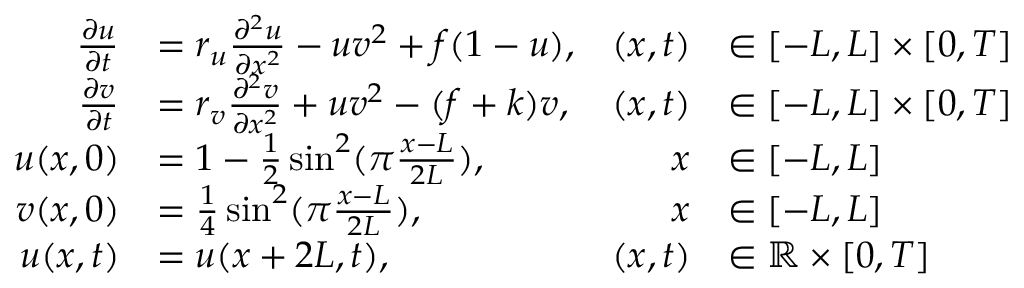<formula> <loc_0><loc_0><loc_500><loc_500>\begin{array} { r l r l } { \frac { \partial u } { \partial t } } & { = r _ { u } \frac { \partial ^ { 2 } u } { \partial x ^ { 2 } } - u v ^ { 2 } + f ( 1 - u ) , } & { ( x , t ) } & { \in [ - L , L ] \times [ 0 , T ] } \\ { \frac { \partial v } { \partial t } } & { = r _ { v } \frac { \partial ^ { 2 } v } { \partial x ^ { 2 } } + u v ^ { 2 } - ( f + k ) v , } & { ( x , t ) } & { \in [ - L , L ] \times [ 0 , T ] } \\ { u ( x , 0 ) } & { = 1 - \frac { 1 } { 2 } \sin ^ { 2 } ( \pi \frac { x - L } { 2 L } ) , } & { x } & { \in [ - L , L ] } \\ { v ( x , 0 ) } & { = \frac { 1 } { 4 } \sin ^ { 2 } ( \pi \frac { x - L } { 2 L } ) , } & { x } & { \in [ - L , L ] } \\ { u ( x , t ) } & { = u ( x + 2 L , t ) , } & { ( x , t ) } & { \in \mathbb { R } \times [ 0 , T ] } \end{array}</formula> 